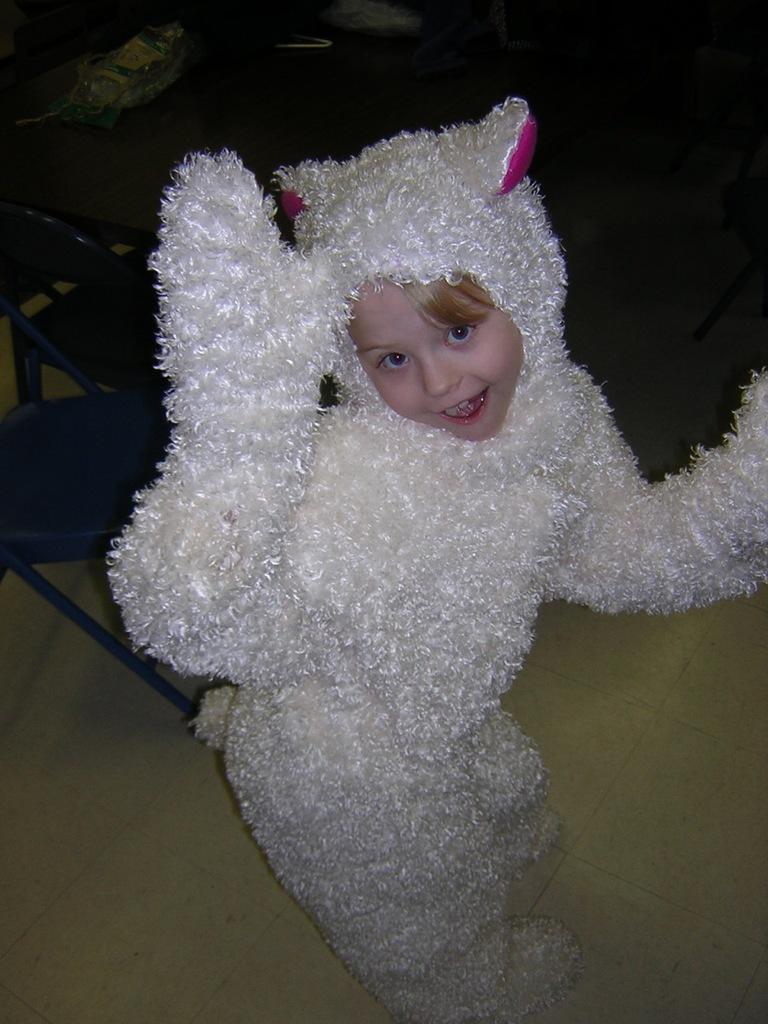Please provide a concise description of this image. In the center of the image there is a girl wearing a costume. In the background of the image there are chairs. At the bottom of the image there is floor. 